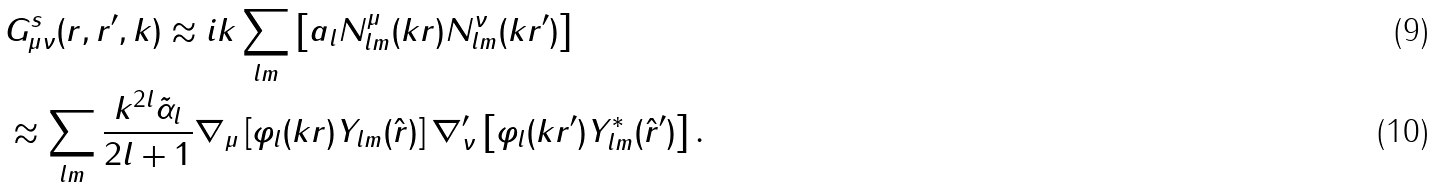Convert formula to latex. <formula><loc_0><loc_0><loc_500><loc_500>& G ^ { s } _ { \mu \nu } ( { r } , { r ^ { \prime } } , { k } ) \approx i k \sum _ { l m } \left [ a _ { l } N ^ { \mu } _ { l m } ( k r ) N ^ { \nu } _ { l m } ( k r ^ { \prime } ) \right ] \\ & \approx \sum _ { l m } \frac { k ^ { 2 l } \tilde { \alpha } _ { l } } { 2 l + 1 } \nabla _ { \mu } \left [ \varphi _ { l } ( k r ) Y _ { l m } ( \hat { r } ) \right ] \nabla ^ { \prime } _ { \nu } \left [ \varphi _ { l } ( k r ^ { \prime } ) Y ^ { * } _ { l m } ( \hat { r } ^ { \prime } ) \right ] .</formula> 